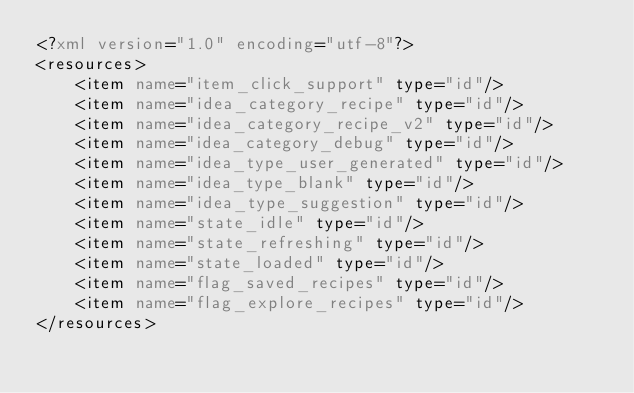Convert code to text. <code><loc_0><loc_0><loc_500><loc_500><_XML_><?xml version="1.0" encoding="utf-8"?>
<resources>
    <item name="item_click_support" type="id"/>
    <item name="idea_category_recipe" type="id"/>
    <item name="idea_category_recipe_v2" type="id"/>
    <item name="idea_category_debug" type="id"/>
    <item name="idea_type_user_generated" type="id"/>
    <item name="idea_type_blank" type="id"/>
    <item name="idea_type_suggestion" type="id"/>
    <item name="state_idle" type="id"/>
    <item name="state_refreshing" type="id"/>
    <item name="state_loaded" type="id"/>
    <item name="flag_saved_recipes" type="id"/>
    <item name="flag_explore_recipes" type="id"/>
</resources></code> 